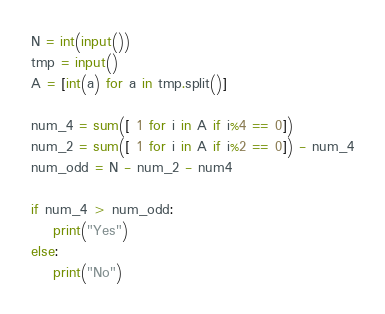<code> <loc_0><loc_0><loc_500><loc_500><_Python_>N = int(input())
tmp = input()
A = [int(a) for a in tmp.split()]

num_4 = sum([ 1 for i in A if i%4 == 0])
num_2 = sum([ 1 for i in A if i%2 == 0]) - num_4
num_odd = N - num_2 - num4

if num_4 > num_odd:
    print("Yes")
else:
    print("No")</code> 